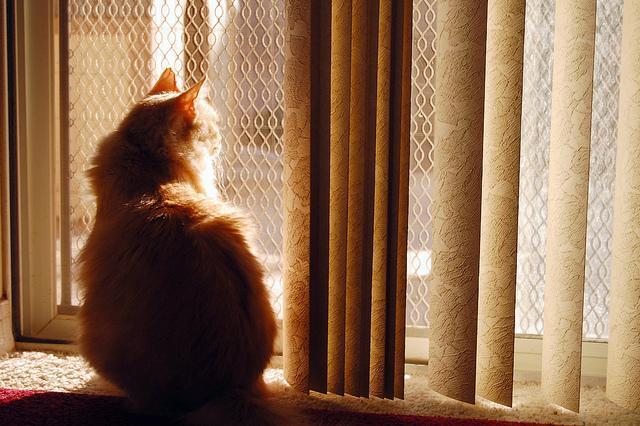How many cats are there?
Give a very brief answer. 1. 